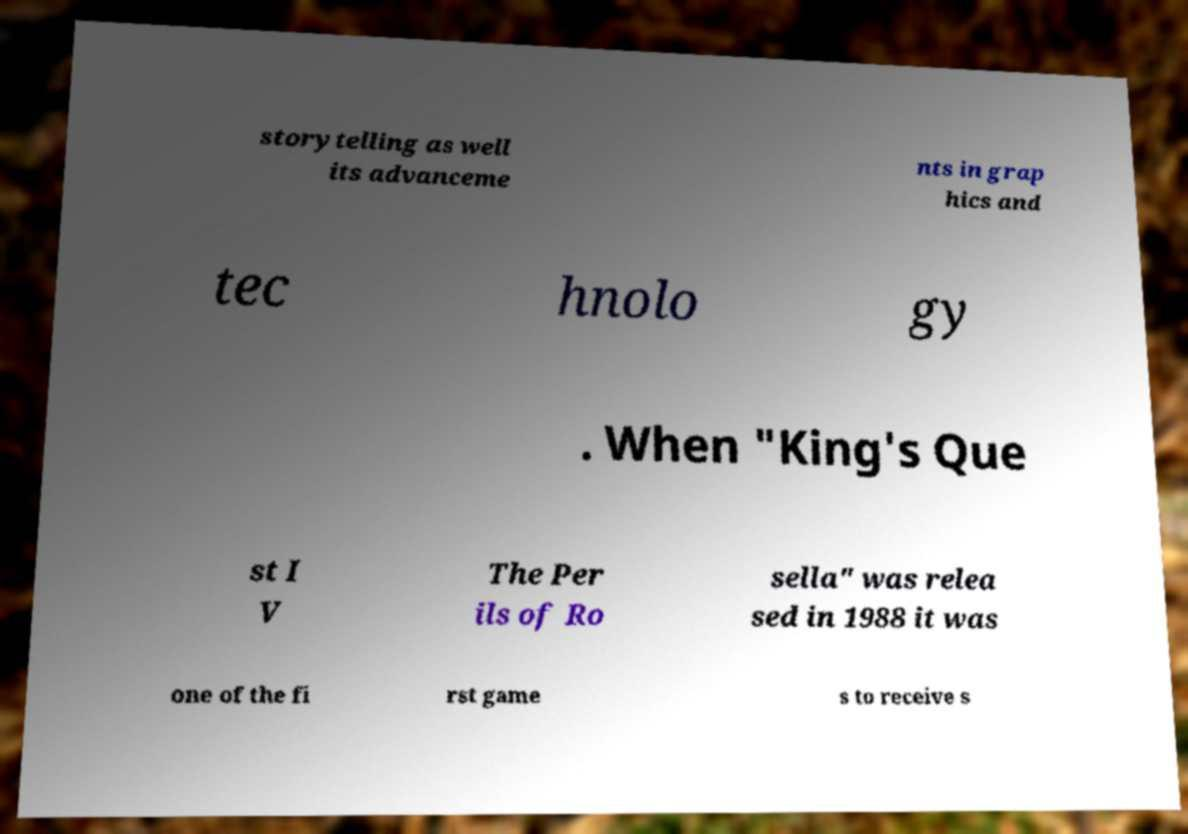Can you read and provide the text displayed in the image?This photo seems to have some interesting text. Can you extract and type it out for me? storytelling as well its advanceme nts in grap hics and tec hnolo gy . When "King's Que st I V The Per ils of Ro sella" was relea sed in 1988 it was one of the fi rst game s to receive s 